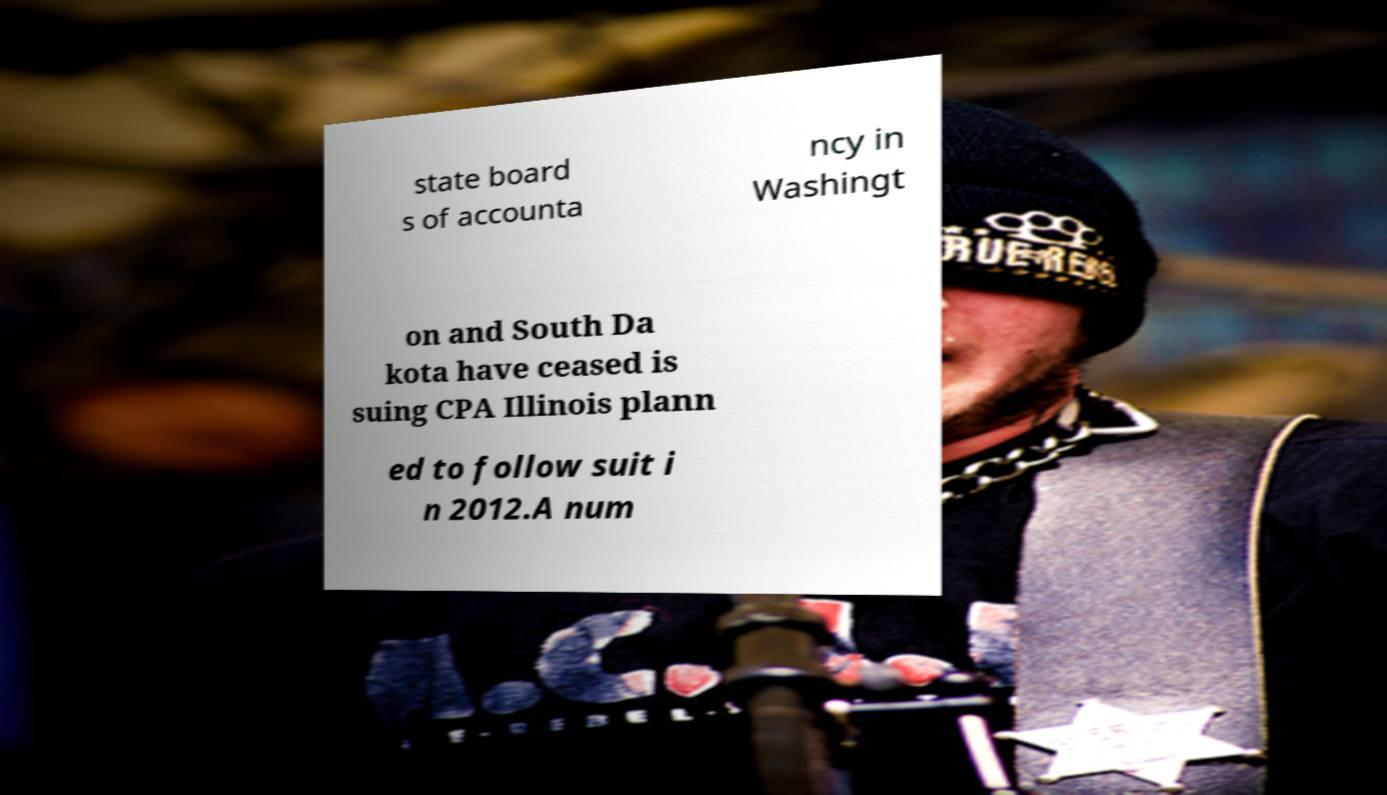Please read and relay the text visible in this image. What does it say? state board s of accounta ncy in Washingt on and South Da kota have ceased is suing CPA Illinois plann ed to follow suit i n 2012.A num 